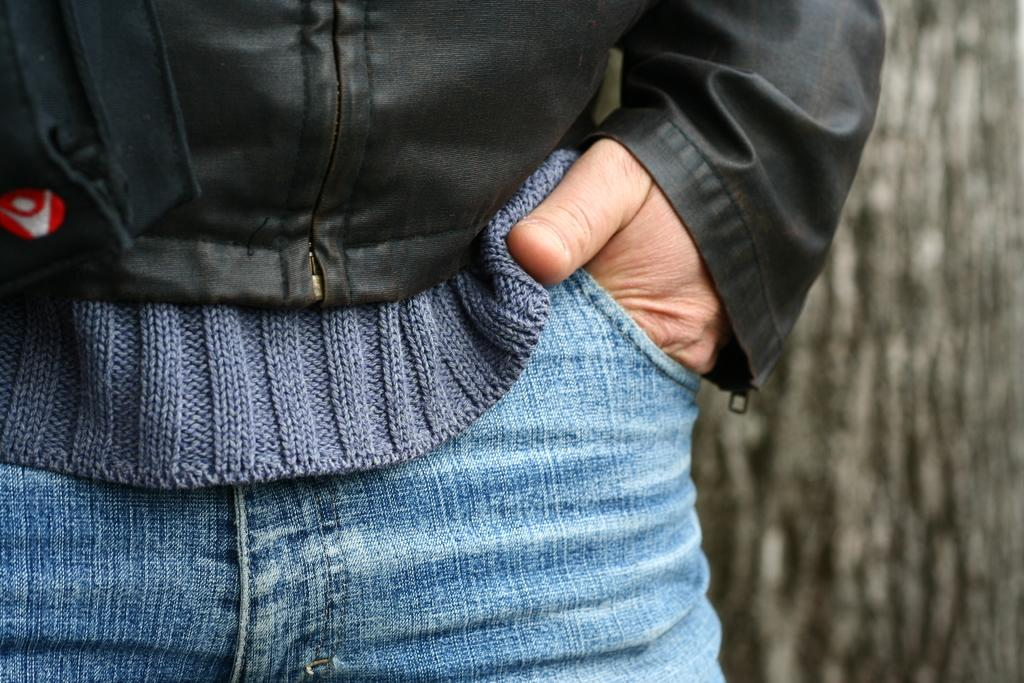What is the main subject of the image? There is a person in the image. What is the person wearing? The person is wearing a black jacket and blue jeans. What can be seen in the background of the image? There is a tree in the background of the image. What type of grape is the person holding in the image? There is no grape present in the image; the person is not holding any fruit. How much sugar is visible in the image? There is no sugar visible in the image. 